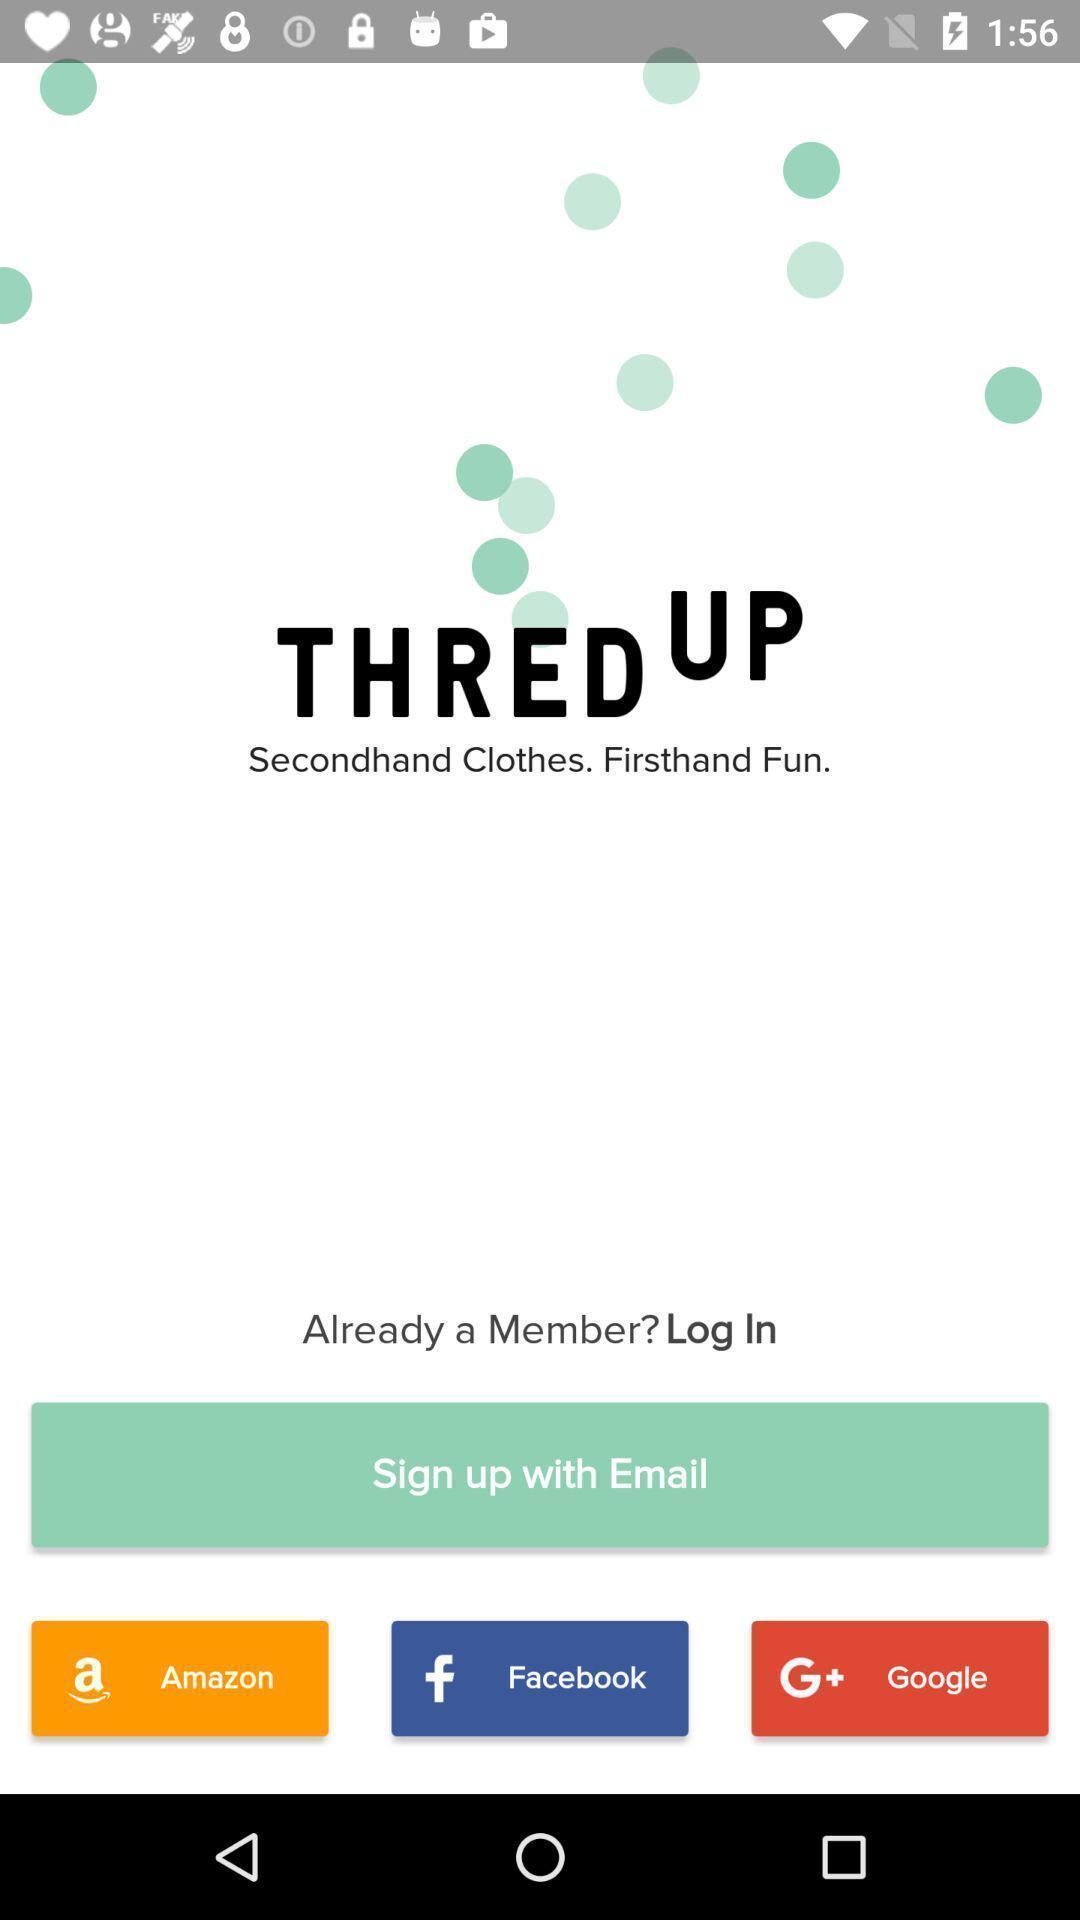What can you discern from this picture? Welcome page for an app. 